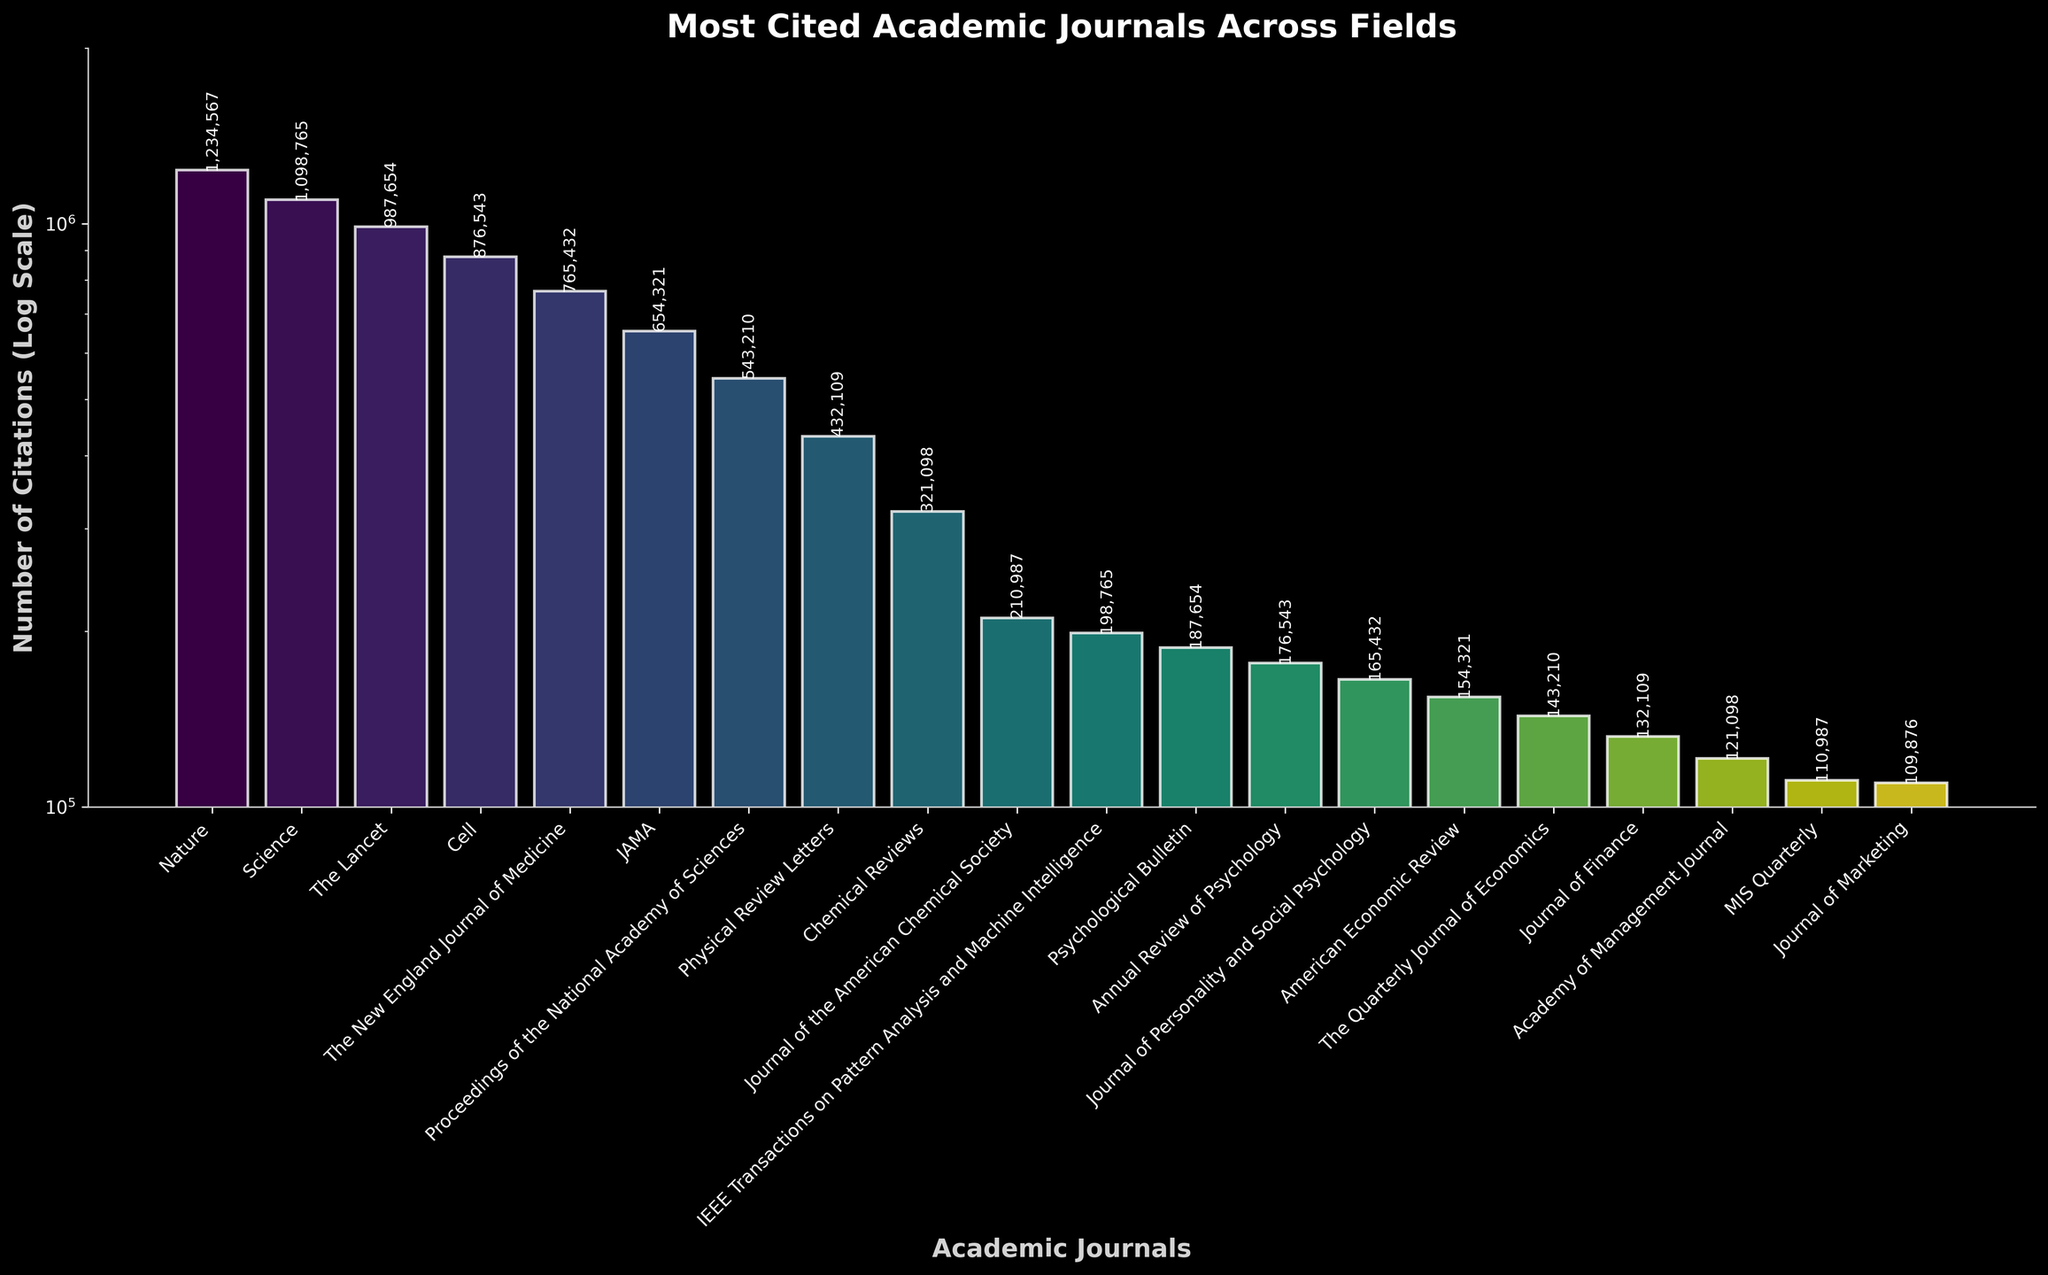What is the most cited academic journal? The bar representing "Nature" is the tallest and has the highest value labeled on it.
Answer: Nature Which journal has the fewest citations? The bar for "Journal of Marketing" is the shortest and has the lowest value labeled on it.
Answer: Journal of Marketing How do the citations of "Science" compare to those of "Nature"? The bar for "Science" is the second tallest and has fewer citations compared to "Nature", as indicated by the numerical labels.
Answer: Fewer What is the difference in citations between "Nature" and "The Lancet"? The labeled values for "Nature" and "The Lancet" are 1,234,567 and 987,654 respectively. Subtract 987,654 from 1,234,567.
Answer: 246,913 How many journals have citations greater than 500,000? By looking at the heights of the bars and their labels, the journals with >500,000 citations are: Nature, Science, The Lancet, Cell, and The New England Journal of Medicine. Count these journals.
Answer: 5 What's the total number of citations for "JAMA" and "Proceedings of the National Academy of Sciences"? Add the citations for "JAMA" (654,321) and "Proceedings of the National Academy of Sciences" (543,210).
Answer: 1,197,531 Which journal’s citations are closest to 1,500,000? The citations are labeled, and we compare the values. "Science" has 1,098,765 citations, which is the closest to 1,500,000.
Answer: Science What's the average number of citations for the journals listed? Sum all label values and divide by the number of journals (20).
Answer: 602,725.75 How does "American Economic Review" compare to "Journal of Finance" in terms of citations? "American Economic Review" has 154,321 citations, and "Journal of Finance" has 132,109 citations; therefore, the former has more.
Answer: More Which journals are within the range of 200,000 to 500,000 citations? Based on the labels, the journals in this range are "Physical Review Letters" (432,109), "Chemical Reviews" (321,098), and "Journal of the American Chemical Society" (210,987).
Answer: 3 